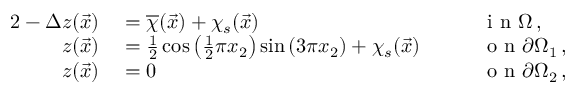<formula> <loc_0><loc_0><loc_500><loc_500>\begin{array} { r l r l } { { 2 } - \Delta z ( \vec { x } ) } & = \overline { \chi } ( \vec { x } ) + \chi _ { s } ( \vec { x } ) \quad } & i n \Omega \, , } \\ { z ( \vec { x } ) } & = \frac { 1 } { 2 } \cos \left ( \frac { 1 } { 2 } \pi x _ { 2 } \right ) \sin \left ( 3 \pi x _ { 2 } \right ) + \chi _ { s } ( \vec { x } ) \quad } & o n \partial \Omega _ { 1 } \, , } \\ { z ( \vec { x } ) } & = 0 \quad } & o n \partial \Omega _ { 2 } \, , } \end{array}</formula> 